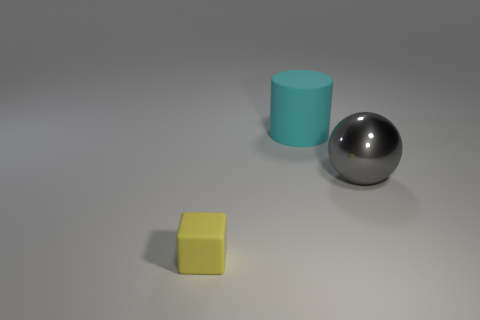Add 1 large purple rubber balls. How many objects exist? 4 Subtract all cylinders. How many objects are left? 2 Subtract 1 cylinders. How many cylinders are left? 0 Subtract 1 gray spheres. How many objects are left? 2 Subtract all blue blocks. Subtract all brown spheres. How many blocks are left? 1 Subtract all yellow cylinders. How many cyan blocks are left? 0 Subtract all blue shiny spheres. Subtract all yellow objects. How many objects are left? 2 Add 2 cubes. How many cubes are left? 3 Add 2 tiny cyan matte blocks. How many tiny cyan matte blocks exist? 2 